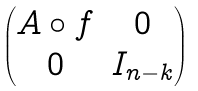Convert formula to latex. <formula><loc_0><loc_0><loc_500><loc_500>\begin{pmatrix} A \circ f & 0 \\ 0 & I _ { n - k } \end{pmatrix}</formula> 